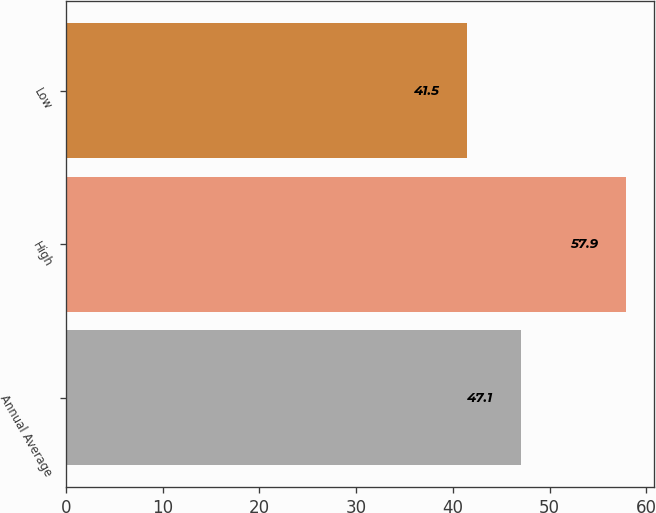Convert chart. <chart><loc_0><loc_0><loc_500><loc_500><bar_chart><fcel>Annual Average<fcel>High<fcel>Low<nl><fcel>47.1<fcel>57.9<fcel>41.5<nl></chart> 